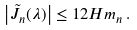Convert formula to latex. <formula><loc_0><loc_0><loc_500><loc_500>\left | \tilde { J } _ { n } ( \lambda ) \right | \leq 1 2 H m _ { n } \, .</formula> 